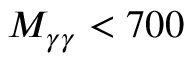Convert formula to latex. <formula><loc_0><loc_0><loc_500><loc_500>M _ { \gamma \gamma } < 7 0 0</formula> 